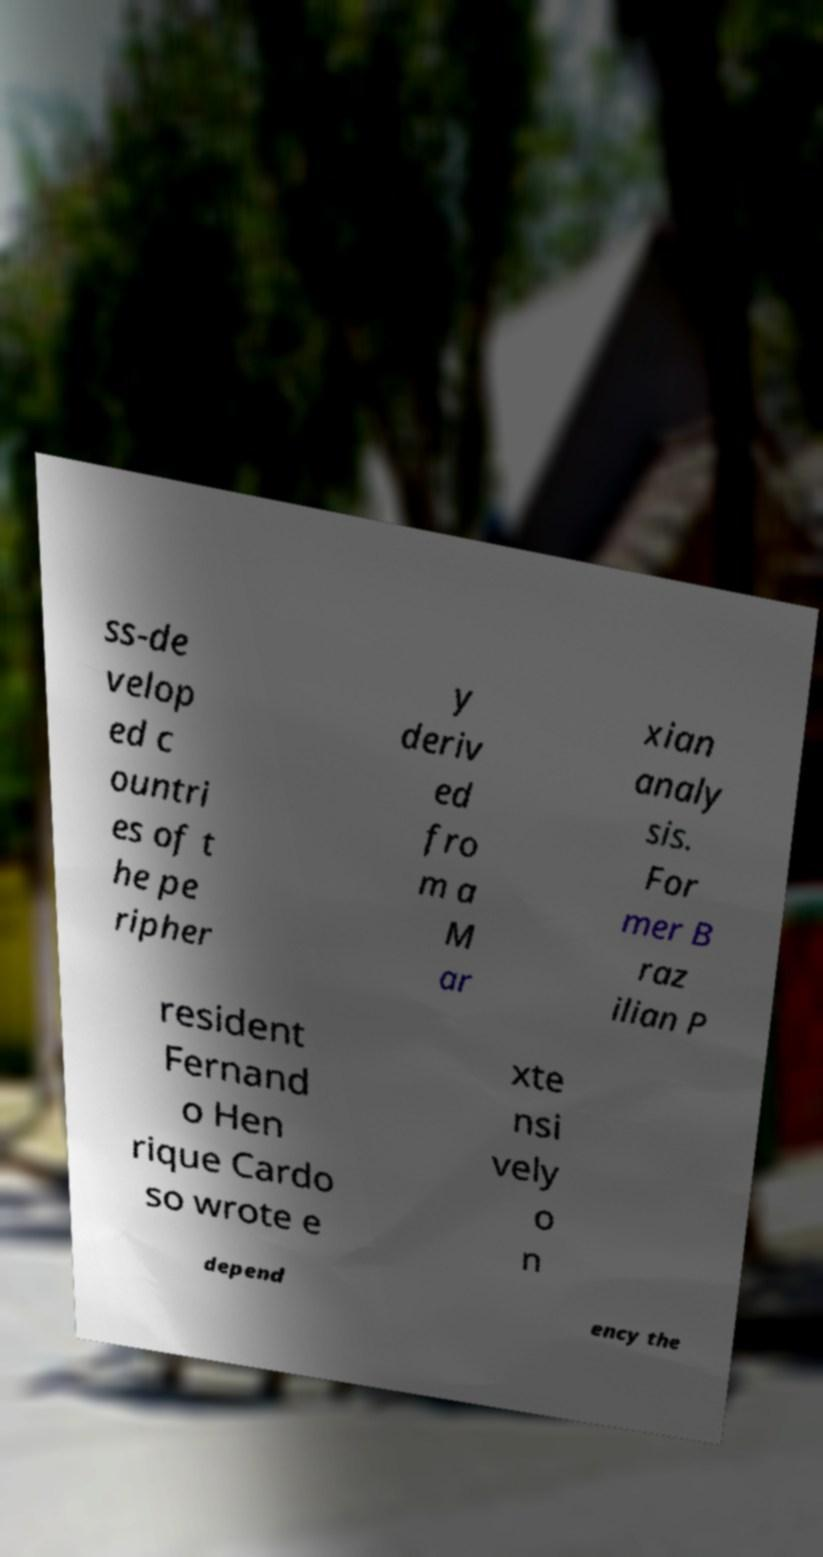I need the written content from this picture converted into text. Can you do that? ss-de velop ed c ountri es of t he pe ripher y deriv ed fro m a M ar xian analy sis. For mer B raz ilian P resident Fernand o Hen rique Cardo so wrote e xte nsi vely o n depend ency the 